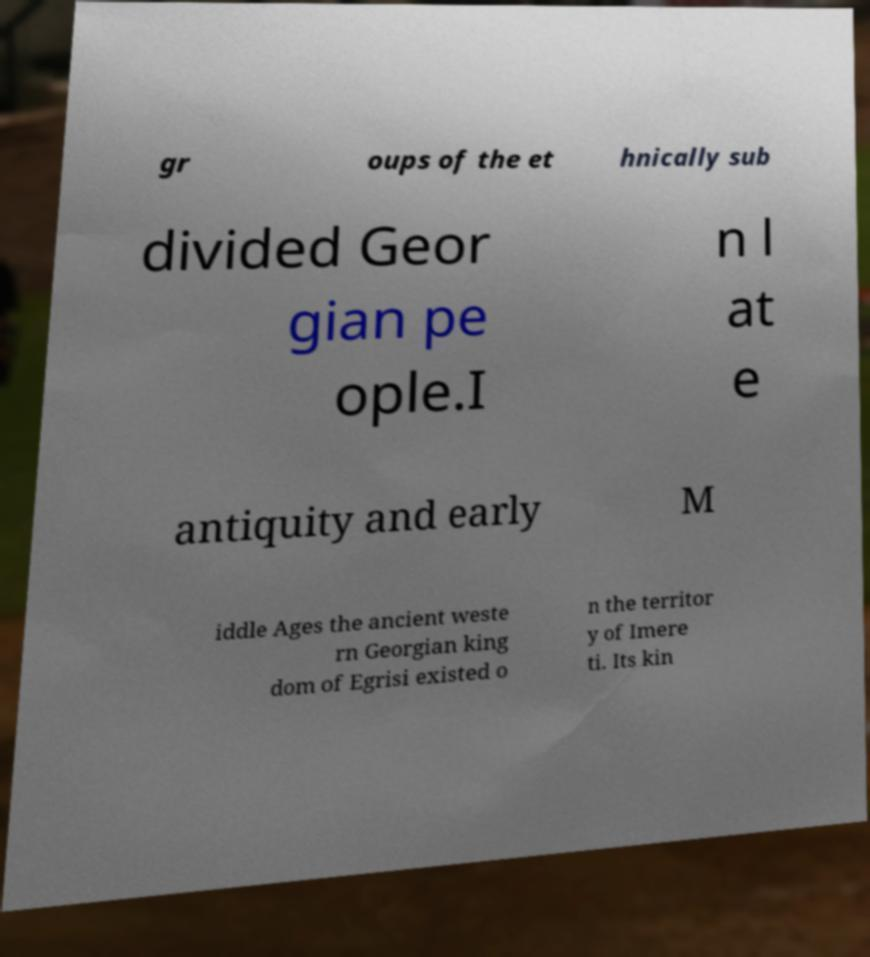Please read and relay the text visible in this image. What does it say? gr oups of the et hnically sub divided Geor gian pe ople.I n l at e antiquity and early M iddle Ages the ancient weste rn Georgian king dom of Egrisi existed o n the territor y of Imere ti. Its kin 